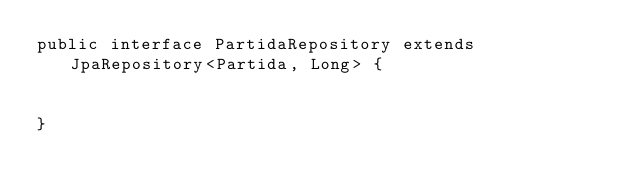Convert code to text. <code><loc_0><loc_0><loc_500><loc_500><_Java_>public interface PartidaRepository extends JpaRepository<Partida, Long> {


}
</code> 